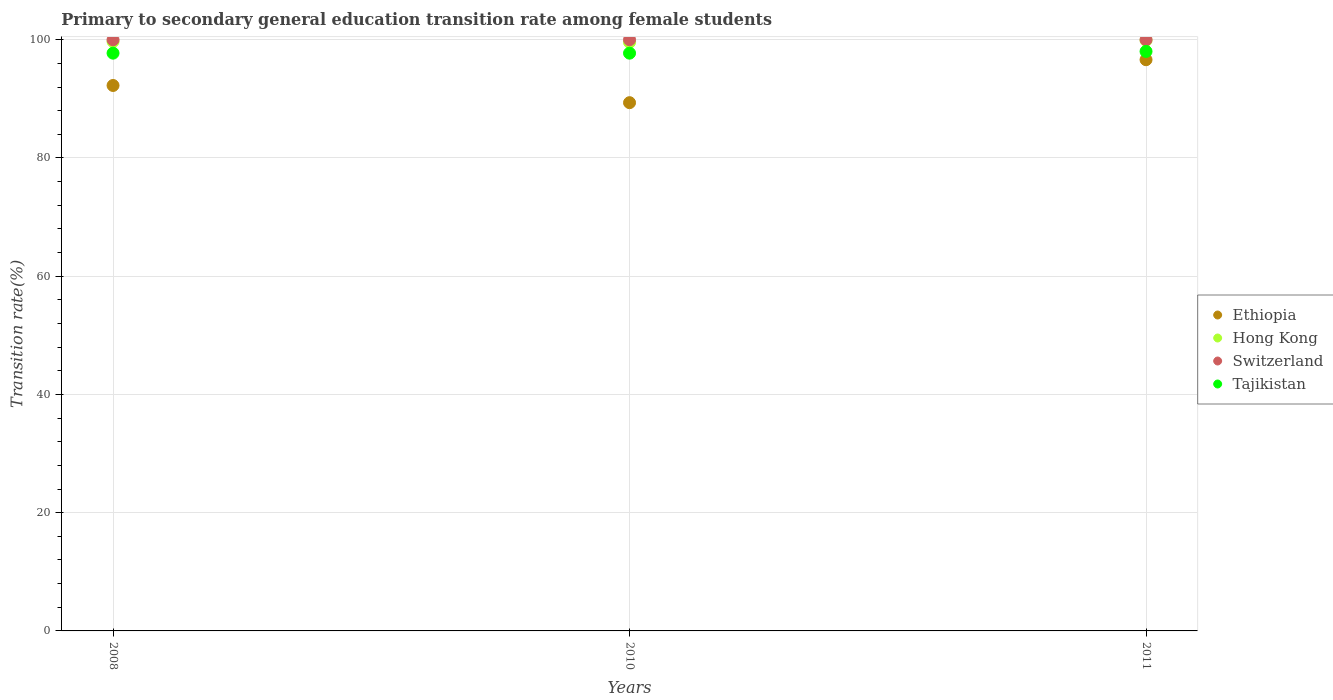How many different coloured dotlines are there?
Your answer should be very brief. 4. What is the transition rate in Tajikistan in 2008?
Keep it short and to the point. 97.73. Across all years, what is the maximum transition rate in Ethiopia?
Your answer should be very brief. 96.62. Across all years, what is the minimum transition rate in Ethiopia?
Ensure brevity in your answer.  89.35. In which year was the transition rate in Tajikistan maximum?
Ensure brevity in your answer.  2011. What is the total transition rate in Hong Kong in the graph?
Your response must be concise. 299.17. What is the difference between the transition rate in Tajikistan in 2011 and the transition rate in Switzerland in 2010?
Your answer should be compact. -1.98. What is the average transition rate in Tajikistan per year?
Make the answer very short. 97.82. In the year 2010, what is the difference between the transition rate in Tajikistan and transition rate in Ethiopia?
Your answer should be very brief. 8.37. In how many years, is the transition rate in Switzerland greater than 40 %?
Provide a succinct answer. 3. What is the ratio of the transition rate in Tajikistan in 2010 to that in 2011?
Provide a succinct answer. 1. Is the difference between the transition rate in Tajikistan in 2008 and 2011 greater than the difference between the transition rate in Ethiopia in 2008 and 2011?
Provide a succinct answer. Yes. What is the difference between the highest and the second highest transition rate in Tajikistan?
Ensure brevity in your answer.  0.3. Is it the case that in every year, the sum of the transition rate in Switzerland and transition rate in Ethiopia  is greater than the sum of transition rate in Hong Kong and transition rate in Tajikistan?
Offer a terse response. Yes. Is the transition rate in Hong Kong strictly greater than the transition rate in Switzerland over the years?
Offer a terse response. No. How many dotlines are there?
Give a very brief answer. 4. What is the difference between two consecutive major ticks on the Y-axis?
Keep it short and to the point. 20. Does the graph contain any zero values?
Give a very brief answer. No. How are the legend labels stacked?
Offer a very short reply. Vertical. What is the title of the graph?
Ensure brevity in your answer.  Primary to secondary general education transition rate among female students. What is the label or title of the X-axis?
Offer a very short reply. Years. What is the label or title of the Y-axis?
Keep it short and to the point. Transition rate(%). What is the Transition rate(%) in Ethiopia in 2008?
Your response must be concise. 92.26. What is the Transition rate(%) in Hong Kong in 2008?
Your answer should be compact. 99.7. What is the Transition rate(%) in Switzerland in 2008?
Give a very brief answer. 100. What is the Transition rate(%) of Tajikistan in 2008?
Your response must be concise. 97.73. What is the Transition rate(%) of Ethiopia in 2010?
Offer a terse response. 89.35. What is the Transition rate(%) of Hong Kong in 2010?
Give a very brief answer. 99.57. What is the Transition rate(%) of Switzerland in 2010?
Give a very brief answer. 100. What is the Transition rate(%) of Tajikistan in 2010?
Ensure brevity in your answer.  97.72. What is the Transition rate(%) in Ethiopia in 2011?
Make the answer very short. 96.62. What is the Transition rate(%) of Hong Kong in 2011?
Provide a succinct answer. 99.9. What is the Transition rate(%) of Switzerland in 2011?
Ensure brevity in your answer.  100. What is the Transition rate(%) of Tajikistan in 2011?
Provide a short and direct response. 98.02. Across all years, what is the maximum Transition rate(%) in Ethiopia?
Keep it short and to the point. 96.62. Across all years, what is the maximum Transition rate(%) in Hong Kong?
Ensure brevity in your answer.  99.9. Across all years, what is the maximum Transition rate(%) of Switzerland?
Keep it short and to the point. 100. Across all years, what is the maximum Transition rate(%) of Tajikistan?
Provide a succinct answer. 98.02. Across all years, what is the minimum Transition rate(%) of Ethiopia?
Provide a short and direct response. 89.35. Across all years, what is the minimum Transition rate(%) in Hong Kong?
Make the answer very short. 99.57. Across all years, what is the minimum Transition rate(%) of Tajikistan?
Provide a short and direct response. 97.72. What is the total Transition rate(%) in Ethiopia in the graph?
Your response must be concise. 278.23. What is the total Transition rate(%) of Hong Kong in the graph?
Keep it short and to the point. 299.17. What is the total Transition rate(%) in Switzerland in the graph?
Provide a short and direct response. 300. What is the total Transition rate(%) in Tajikistan in the graph?
Offer a terse response. 293.47. What is the difference between the Transition rate(%) in Ethiopia in 2008 and that in 2010?
Keep it short and to the point. 2.91. What is the difference between the Transition rate(%) of Hong Kong in 2008 and that in 2010?
Provide a succinct answer. 0.14. What is the difference between the Transition rate(%) in Tajikistan in 2008 and that in 2010?
Keep it short and to the point. 0. What is the difference between the Transition rate(%) in Ethiopia in 2008 and that in 2011?
Keep it short and to the point. -4.36. What is the difference between the Transition rate(%) in Hong Kong in 2008 and that in 2011?
Your response must be concise. -0.2. What is the difference between the Transition rate(%) in Switzerland in 2008 and that in 2011?
Give a very brief answer. 0. What is the difference between the Transition rate(%) in Tajikistan in 2008 and that in 2011?
Your answer should be compact. -0.3. What is the difference between the Transition rate(%) of Ethiopia in 2010 and that in 2011?
Offer a very short reply. -7.27. What is the difference between the Transition rate(%) of Hong Kong in 2010 and that in 2011?
Offer a very short reply. -0.34. What is the difference between the Transition rate(%) in Switzerland in 2010 and that in 2011?
Keep it short and to the point. 0. What is the difference between the Transition rate(%) in Tajikistan in 2010 and that in 2011?
Offer a terse response. -0.3. What is the difference between the Transition rate(%) in Ethiopia in 2008 and the Transition rate(%) in Hong Kong in 2010?
Your answer should be compact. -7.31. What is the difference between the Transition rate(%) in Ethiopia in 2008 and the Transition rate(%) in Switzerland in 2010?
Give a very brief answer. -7.74. What is the difference between the Transition rate(%) of Ethiopia in 2008 and the Transition rate(%) of Tajikistan in 2010?
Offer a very short reply. -5.47. What is the difference between the Transition rate(%) of Hong Kong in 2008 and the Transition rate(%) of Switzerland in 2010?
Offer a very short reply. -0.3. What is the difference between the Transition rate(%) in Hong Kong in 2008 and the Transition rate(%) in Tajikistan in 2010?
Your answer should be compact. 1.98. What is the difference between the Transition rate(%) in Switzerland in 2008 and the Transition rate(%) in Tajikistan in 2010?
Ensure brevity in your answer.  2.28. What is the difference between the Transition rate(%) in Ethiopia in 2008 and the Transition rate(%) in Hong Kong in 2011?
Offer a terse response. -7.64. What is the difference between the Transition rate(%) of Ethiopia in 2008 and the Transition rate(%) of Switzerland in 2011?
Your response must be concise. -7.74. What is the difference between the Transition rate(%) in Ethiopia in 2008 and the Transition rate(%) in Tajikistan in 2011?
Give a very brief answer. -5.76. What is the difference between the Transition rate(%) of Hong Kong in 2008 and the Transition rate(%) of Switzerland in 2011?
Your answer should be compact. -0.3. What is the difference between the Transition rate(%) of Hong Kong in 2008 and the Transition rate(%) of Tajikistan in 2011?
Provide a succinct answer. 1.68. What is the difference between the Transition rate(%) of Switzerland in 2008 and the Transition rate(%) of Tajikistan in 2011?
Offer a terse response. 1.98. What is the difference between the Transition rate(%) in Ethiopia in 2010 and the Transition rate(%) in Hong Kong in 2011?
Offer a terse response. -10.55. What is the difference between the Transition rate(%) in Ethiopia in 2010 and the Transition rate(%) in Switzerland in 2011?
Your response must be concise. -10.65. What is the difference between the Transition rate(%) in Ethiopia in 2010 and the Transition rate(%) in Tajikistan in 2011?
Provide a succinct answer. -8.67. What is the difference between the Transition rate(%) in Hong Kong in 2010 and the Transition rate(%) in Switzerland in 2011?
Offer a very short reply. -0.43. What is the difference between the Transition rate(%) of Hong Kong in 2010 and the Transition rate(%) of Tajikistan in 2011?
Keep it short and to the point. 1.54. What is the difference between the Transition rate(%) of Switzerland in 2010 and the Transition rate(%) of Tajikistan in 2011?
Ensure brevity in your answer.  1.98. What is the average Transition rate(%) of Ethiopia per year?
Offer a terse response. 92.74. What is the average Transition rate(%) of Hong Kong per year?
Ensure brevity in your answer.  99.72. What is the average Transition rate(%) in Switzerland per year?
Provide a succinct answer. 100. What is the average Transition rate(%) of Tajikistan per year?
Give a very brief answer. 97.82. In the year 2008, what is the difference between the Transition rate(%) in Ethiopia and Transition rate(%) in Hong Kong?
Provide a short and direct response. -7.44. In the year 2008, what is the difference between the Transition rate(%) of Ethiopia and Transition rate(%) of Switzerland?
Provide a short and direct response. -7.74. In the year 2008, what is the difference between the Transition rate(%) in Ethiopia and Transition rate(%) in Tajikistan?
Provide a succinct answer. -5.47. In the year 2008, what is the difference between the Transition rate(%) in Hong Kong and Transition rate(%) in Switzerland?
Keep it short and to the point. -0.3. In the year 2008, what is the difference between the Transition rate(%) in Hong Kong and Transition rate(%) in Tajikistan?
Offer a terse response. 1.98. In the year 2008, what is the difference between the Transition rate(%) of Switzerland and Transition rate(%) of Tajikistan?
Your response must be concise. 2.27. In the year 2010, what is the difference between the Transition rate(%) in Ethiopia and Transition rate(%) in Hong Kong?
Your answer should be very brief. -10.21. In the year 2010, what is the difference between the Transition rate(%) in Ethiopia and Transition rate(%) in Switzerland?
Your response must be concise. -10.65. In the year 2010, what is the difference between the Transition rate(%) of Ethiopia and Transition rate(%) of Tajikistan?
Offer a terse response. -8.37. In the year 2010, what is the difference between the Transition rate(%) in Hong Kong and Transition rate(%) in Switzerland?
Give a very brief answer. -0.43. In the year 2010, what is the difference between the Transition rate(%) of Hong Kong and Transition rate(%) of Tajikistan?
Offer a terse response. 1.84. In the year 2010, what is the difference between the Transition rate(%) of Switzerland and Transition rate(%) of Tajikistan?
Give a very brief answer. 2.28. In the year 2011, what is the difference between the Transition rate(%) of Ethiopia and Transition rate(%) of Hong Kong?
Offer a very short reply. -3.29. In the year 2011, what is the difference between the Transition rate(%) of Ethiopia and Transition rate(%) of Switzerland?
Your answer should be very brief. -3.38. In the year 2011, what is the difference between the Transition rate(%) of Ethiopia and Transition rate(%) of Tajikistan?
Give a very brief answer. -1.4. In the year 2011, what is the difference between the Transition rate(%) in Hong Kong and Transition rate(%) in Switzerland?
Your response must be concise. -0.1. In the year 2011, what is the difference between the Transition rate(%) of Hong Kong and Transition rate(%) of Tajikistan?
Provide a succinct answer. 1.88. In the year 2011, what is the difference between the Transition rate(%) in Switzerland and Transition rate(%) in Tajikistan?
Make the answer very short. 1.98. What is the ratio of the Transition rate(%) in Ethiopia in 2008 to that in 2010?
Provide a short and direct response. 1.03. What is the ratio of the Transition rate(%) in Tajikistan in 2008 to that in 2010?
Your answer should be compact. 1. What is the ratio of the Transition rate(%) of Ethiopia in 2008 to that in 2011?
Provide a succinct answer. 0.95. What is the ratio of the Transition rate(%) of Switzerland in 2008 to that in 2011?
Your response must be concise. 1. What is the ratio of the Transition rate(%) of Tajikistan in 2008 to that in 2011?
Offer a terse response. 1. What is the ratio of the Transition rate(%) of Ethiopia in 2010 to that in 2011?
Offer a terse response. 0.92. What is the ratio of the Transition rate(%) in Switzerland in 2010 to that in 2011?
Offer a terse response. 1. What is the ratio of the Transition rate(%) of Tajikistan in 2010 to that in 2011?
Ensure brevity in your answer.  1. What is the difference between the highest and the second highest Transition rate(%) in Ethiopia?
Your response must be concise. 4.36. What is the difference between the highest and the second highest Transition rate(%) of Hong Kong?
Keep it short and to the point. 0.2. What is the difference between the highest and the second highest Transition rate(%) of Switzerland?
Offer a very short reply. 0. What is the difference between the highest and the second highest Transition rate(%) in Tajikistan?
Give a very brief answer. 0.3. What is the difference between the highest and the lowest Transition rate(%) in Ethiopia?
Your answer should be compact. 7.27. What is the difference between the highest and the lowest Transition rate(%) in Hong Kong?
Offer a terse response. 0.34. What is the difference between the highest and the lowest Transition rate(%) of Switzerland?
Keep it short and to the point. 0. What is the difference between the highest and the lowest Transition rate(%) of Tajikistan?
Your response must be concise. 0.3. 